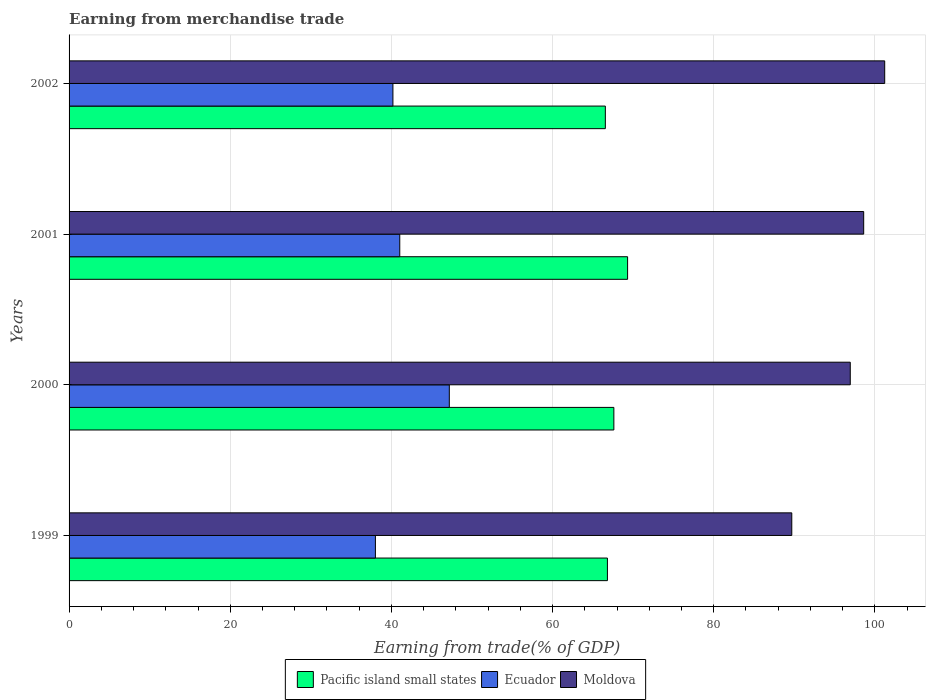How many groups of bars are there?
Your response must be concise. 4. Are the number of bars on each tick of the Y-axis equal?
Provide a short and direct response. Yes. How many bars are there on the 2nd tick from the top?
Provide a succinct answer. 3. How many bars are there on the 2nd tick from the bottom?
Give a very brief answer. 3. What is the label of the 3rd group of bars from the top?
Ensure brevity in your answer.  2000. What is the earnings from trade in Pacific island small states in 2000?
Make the answer very short. 67.6. Across all years, what is the maximum earnings from trade in Ecuador?
Provide a short and direct response. 47.19. Across all years, what is the minimum earnings from trade in Ecuador?
Provide a short and direct response. 38.01. In which year was the earnings from trade in Moldova maximum?
Give a very brief answer. 2002. What is the total earnings from trade in Moldova in the graph?
Make the answer very short. 386.44. What is the difference between the earnings from trade in Ecuador in 1999 and that in 2001?
Your answer should be very brief. -3.02. What is the difference between the earnings from trade in Pacific island small states in 2001 and the earnings from trade in Ecuador in 2002?
Offer a very short reply. 29.12. What is the average earnings from trade in Moldova per year?
Your answer should be compact. 96.61. In the year 1999, what is the difference between the earnings from trade in Moldova and earnings from trade in Pacific island small states?
Offer a terse response. 22.88. What is the ratio of the earnings from trade in Ecuador in 1999 to that in 2002?
Provide a succinct answer. 0.95. Is the earnings from trade in Ecuador in 1999 less than that in 2001?
Offer a very short reply. Yes. Is the difference between the earnings from trade in Moldova in 2001 and 2002 greater than the difference between the earnings from trade in Pacific island small states in 2001 and 2002?
Your response must be concise. No. What is the difference between the highest and the second highest earnings from trade in Moldova?
Ensure brevity in your answer.  2.61. What is the difference between the highest and the lowest earnings from trade in Ecuador?
Offer a very short reply. 9.17. Is the sum of the earnings from trade in Moldova in 1999 and 2000 greater than the maximum earnings from trade in Ecuador across all years?
Your answer should be very brief. Yes. What does the 2nd bar from the top in 2001 represents?
Ensure brevity in your answer.  Ecuador. What does the 1st bar from the bottom in 1999 represents?
Provide a succinct answer. Pacific island small states. How many years are there in the graph?
Your response must be concise. 4. Does the graph contain grids?
Your answer should be compact. Yes. What is the title of the graph?
Provide a succinct answer. Earning from merchandise trade. What is the label or title of the X-axis?
Ensure brevity in your answer.  Earning from trade(% of GDP). What is the Earning from trade(% of GDP) of Pacific island small states in 1999?
Offer a terse response. 66.8. What is the Earning from trade(% of GDP) of Ecuador in 1999?
Your answer should be compact. 38.01. What is the Earning from trade(% of GDP) in Moldova in 1999?
Keep it short and to the point. 89.68. What is the Earning from trade(% of GDP) of Pacific island small states in 2000?
Offer a very short reply. 67.6. What is the Earning from trade(% of GDP) of Ecuador in 2000?
Provide a succinct answer. 47.19. What is the Earning from trade(% of GDP) in Moldova in 2000?
Your answer should be very brief. 96.94. What is the Earning from trade(% of GDP) in Pacific island small states in 2001?
Make the answer very short. 69.31. What is the Earning from trade(% of GDP) of Ecuador in 2001?
Make the answer very short. 41.04. What is the Earning from trade(% of GDP) of Moldova in 2001?
Give a very brief answer. 98.6. What is the Earning from trade(% of GDP) in Pacific island small states in 2002?
Offer a very short reply. 66.55. What is the Earning from trade(% of GDP) in Ecuador in 2002?
Make the answer very short. 40.19. What is the Earning from trade(% of GDP) of Moldova in 2002?
Make the answer very short. 101.21. Across all years, what is the maximum Earning from trade(% of GDP) in Pacific island small states?
Make the answer very short. 69.31. Across all years, what is the maximum Earning from trade(% of GDP) of Ecuador?
Ensure brevity in your answer.  47.19. Across all years, what is the maximum Earning from trade(% of GDP) of Moldova?
Keep it short and to the point. 101.21. Across all years, what is the minimum Earning from trade(% of GDP) of Pacific island small states?
Your answer should be compact. 66.55. Across all years, what is the minimum Earning from trade(% of GDP) in Ecuador?
Give a very brief answer. 38.01. Across all years, what is the minimum Earning from trade(% of GDP) of Moldova?
Your answer should be compact. 89.68. What is the total Earning from trade(% of GDP) in Pacific island small states in the graph?
Provide a short and direct response. 270.27. What is the total Earning from trade(% of GDP) of Ecuador in the graph?
Make the answer very short. 166.42. What is the total Earning from trade(% of GDP) in Moldova in the graph?
Your answer should be compact. 386.44. What is the difference between the Earning from trade(% of GDP) of Pacific island small states in 1999 and that in 2000?
Offer a very short reply. -0.8. What is the difference between the Earning from trade(% of GDP) in Ecuador in 1999 and that in 2000?
Keep it short and to the point. -9.17. What is the difference between the Earning from trade(% of GDP) of Moldova in 1999 and that in 2000?
Ensure brevity in your answer.  -7.26. What is the difference between the Earning from trade(% of GDP) of Pacific island small states in 1999 and that in 2001?
Provide a short and direct response. -2.5. What is the difference between the Earning from trade(% of GDP) in Ecuador in 1999 and that in 2001?
Offer a very short reply. -3.02. What is the difference between the Earning from trade(% of GDP) of Moldova in 1999 and that in 2001?
Your response must be concise. -8.92. What is the difference between the Earning from trade(% of GDP) in Pacific island small states in 1999 and that in 2002?
Your answer should be very brief. 0.26. What is the difference between the Earning from trade(% of GDP) of Ecuador in 1999 and that in 2002?
Keep it short and to the point. -2.17. What is the difference between the Earning from trade(% of GDP) in Moldova in 1999 and that in 2002?
Keep it short and to the point. -11.53. What is the difference between the Earning from trade(% of GDP) in Pacific island small states in 2000 and that in 2001?
Provide a succinct answer. -1.7. What is the difference between the Earning from trade(% of GDP) in Ecuador in 2000 and that in 2001?
Provide a short and direct response. 6.15. What is the difference between the Earning from trade(% of GDP) in Moldova in 2000 and that in 2001?
Give a very brief answer. -1.66. What is the difference between the Earning from trade(% of GDP) in Pacific island small states in 2000 and that in 2002?
Give a very brief answer. 1.06. What is the difference between the Earning from trade(% of GDP) in Ecuador in 2000 and that in 2002?
Ensure brevity in your answer.  7. What is the difference between the Earning from trade(% of GDP) of Moldova in 2000 and that in 2002?
Offer a very short reply. -4.27. What is the difference between the Earning from trade(% of GDP) of Pacific island small states in 2001 and that in 2002?
Keep it short and to the point. 2.76. What is the difference between the Earning from trade(% of GDP) of Ecuador in 2001 and that in 2002?
Your answer should be compact. 0.85. What is the difference between the Earning from trade(% of GDP) in Moldova in 2001 and that in 2002?
Your response must be concise. -2.61. What is the difference between the Earning from trade(% of GDP) in Pacific island small states in 1999 and the Earning from trade(% of GDP) in Ecuador in 2000?
Provide a succinct answer. 19.62. What is the difference between the Earning from trade(% of GDP) of Pacific island small states in 1999 and the Earning from trade(% of GDP) of Moldova in 2000?
Provide a succinct answer. -30.14. What is the difference between the Earning from trade(% of GDP) of Ecuador in 1999 and the Earning from trade(% of GDP) of Moldova in 2000?
Make the answer very short. -58.93. What is the difference between the Earning from trade(% of GDP) in Pacific island small states in 1999 and the Earning from trade(% of GDP) in Ecuador in 2001?
Your answer should be compact. 25.77. What is the difference between the Earning from trade(% of GDP) of Pacific island small states in 1999 and the Earning from trade(% of GDP) of Moldova in 2001?
Ensure brevity in your answer.  -31.8. What is the difference between the Earning from trade(% of GDP) of Ecuador in 1999 and the Earning from trade(% of GDP) of Moldova in 2001?
Provide a succinct answer. -60.59. What is the difference between the Earning from trade(% of GDP) of Pacific island small states in 1999 and the Earning from trade(% of GDP) of Ecuador in 2002?
Make the answer very short. 26.62. What is the difference between the Earning from trade(% of GDP) of Pacific island small states in 1999 and the Earning from trade(% of GDP) of Moldova in 2002?
Offer a very short reply. -34.41. What is the difference between the Earning from trade(% of GDP) of Ecuador in 1999 and the Earning from trade(% of GDP) of Moldova in 2002?
Your answer should be compact. -63.2. What is the difference between the Earning from trade(% of GDP) of Pacific island small states in 2000 and the Earning from trade(% of GDP) of Ecuador in 2001?
Provide a short and direct response. 26.57. What is the difference between the Earning from trade(% of GDP) in Pacific island small states in 2000 and the Earning from trade(% of GDP) in Moldova in 2001?
Provide a succinct answer. -31. What is the difference between the Earning from trade(% of GDP) in Ecuador in 2000 and the Earning from trade(% of GDP) in Moldova in 2001?
Offer a terse response. -51.42. What is the difference between the Earning from trade(% of GDP) in Pacific island small states in 2000 and the Earning from trade(% of GDP) in Ecuador in 2002?
Your answer should be very brief. 27.42. What is the difference between the Earning from trade(% of GDP) of Pacific island small states in 2000 and the Earning from trade(% of GDP) of Moldova in 2002?
Your answer should be compact. -33.61. What is the difference between the Earning from trade(% of GDP) of Ecuador in 2000 and the Earning from trade(% of GDP) of Moldova in 2002?
Provide a succinct answer. -54.03. What is the difference between the Earning from trade(% of GDP) of Pacific island small states in 2001 and the Earning from trade(% of GDP) of Ecuador in 2002?
Provide a succinct answer. 29.12. What is the difference between the Earning from trade(% of GDP) of Pacific island small states in 2001 and the Earning from trade(% of GDP) of Moldova in 2002?
Provide a succinct answer. -31.91. What is the difference between the Earning from trade(% of GDP) of Ecuador in 2001 and the Earning from trade(% of GDP) of Moldova in 2002?
Provide a succinct answer. -60.18. What is the average Earning from trade(% of GDP) of Pacific island small states per year?
Keep it short and to the point. 67.57. What is the average Earning from trade(% of GDP) of Ecuador per year?
Your response must be concise. 41.61. What is the average Earning from trade(% of GDP) in Moldova per year?
Your response must be concise. 96.61. In the year 1999, what is the difference between the Earning from trade(% of GDP) in Pacific island small states and Earning from trade(% of GDP) in Ecuador?
Provide a short and direct response. 28.79. In the year 1999, what is the difference between the Earning from trade(% of GDP) in Pacific island small states and Earning from trade(% of GDP) in Moldova?
Your answer should be very brief. -22.88. In the year 1999, what is the difference between the Earning from trade(% of GDP) in Ecuador and Earning from trade(% of GDP) in Moldova?
Provide a succinct answer. -51.67. In the year 2000, what is the difference between the Earning from trade(% of GDP) in Pacific island small states and Earning from trade(% of GDP) in Ecuador?
Offer a terse response. 20.42. In the year 2000, what is the difference between the Earning from trade(% of GDP) of Pacific island small states and Earning from trade(% of GDP) of Moldova?
Your answer should be very brief. -29.34. In the year 2000, what is the difference between the Earning from trade(% of GDP) of Ecuador and Earning from trade(% of GDP) of Moldova?
Give a very brief answer. -49.76. In the year 2001, what is the difference between the Earning from trade(% of GDP) in Pacific island small states and Earning from trade(% of GDP) in Ecuador?
Your answer should be compact. 28.27. In the year 2001, what is the difference between the Earning from trade(% of GDP) in Pacific island small states and Earning from trade(% of GDP) in Moldova?
Give a very brief answer. -29.3. In the year 2001, what is the difference between the Earning from trade(% of GDP) of Ecuador and Earning from trade(% of GDP) of Moldova?
Offer a terse response. -57.57. In the year 2002, what is the difference between the Earning from trade(% of GDP) in Pacific island small states and Earning from trade(% of GDP) in Ecuador?
Your response must be concise. 26.36. In the year 2002, what is the difference between the Earning from trade(% of GDP) in Pacific island small states and Earning from trade(% of GDP) in Moldova?
Give a very brief answer. -34.67. In the year 2002, what is the difference between the Earning from trade(% of GDP) of Ecuador and Earning from trade(% of GDP) of Moldova?
Provide a short and direct response. -61.03. What is the ratio of the Earning from trade(% of GDP) in Pacific island small states in 1999 to that in 2000?
Provide a succinct answer. 0.99. What is the ratio of the Earning from trade(% of GDP) in Ecuador in 1999 to that in 2000?
Ensure brevity in your answer.  0.81. What is the ratio of the Earning from trade(% of GDP) of Moldova in 1999 to that in 2000?
Offer a terse response. 0.93. What is the ratio of the Earning from trade(% of GDP) in Pacific island small states in 1999 to that in 2001?
Make the answer very short. 0.96. What is the ratio of the Earning from trade(% of GDP) of Ecuador in 1999 to that in 2001?
Make the answer very short. 0.93. What is the ratio of the Earning from trade(% of GDP) in Moldova in 1999 to that in 2001?
Your answer should be very brief. 0.91. What is the ratio of the Earning from trade(% of GDP) of Pacific island small states in 1999 to that in 2002?
Provide a succinct answer. 1. What is the ratio of the Earning from trade(% of GDP) of Ecuador in 1999 to that in 2002?
Your answer should be compact. 0.95. What is the ratio of the Earning from trade(% of GDP) in Moldova in 1999 to that in 2002?
Provide a succinct answer. 0.89. What is the ratio of the Earning from trade(% of GDP) in Pacific island small states in 2000 to that in 2001?
Your answer should be very brief. 0.98. What is the ratio of the Earning from trade(% of GDP) in Ecuador in 2000 to that in 2001?
Offer a terse response. 1.15. What is the ratio of the Earning from trade(% of GDP) in Moldova in 2000 to that in 2001?
Keep it short and to the point. 0.98. What is the ratio of the Earning from trade(% of GDP) of Pacific island small states in 2000 to that in 2002?
Your response must be concise. 1.02. What is the ratio of the Earning from trade(% of GDP) of Ecuador in 2000 to that in 2002?
Offer a terse response. 1.17. What is the ratio of the Earning from trade(% of GDP) of Moldova in 2000 to that in 2002?
Give a very brief answer. 0.96. What is the ratio of the Earning from trade(% of GDP) in Pacific island small states in 2001 to that in 2002?
Provide a short and direct response. 1.04. What is the ratio of the Earning from trade(% of GDP) in Ecuador in 2001 to that in 2002?
Keep it short and to the point. 1.02. What is the ratio of the Earning from trade(% of GDP) of Moldova in 2001 to that in 2002?
Your answer should be very brief. 0.97. What is the difference between the highest and the second highest Earning from trade(% of GDP) in Pacific island small states?
Offer a terse response. 1.7. What is the difference between the highest and the second highest Earning from trade(% of GDP) of Ecuador?
Offer a terse response. 6.15. What is the difference between the highest and the second highest Earning from trade(% of GDP) in Moldova?
Ensure brevity in your answer.  2.61. What is the difference between the highest and the lowest Earning from trade(% of GDP) in Pacific island small states?
Your answer should be compact. 2.76. What is the difference between the highest and the lowest Earning from trade(% of GDP) of Ecuador?
Provide a short and direct response. 9.17. What is the difference between the highest and the lowest Earning from trade(% of GDP) of Moldova?
Provide a succinct answer. 11.53. 